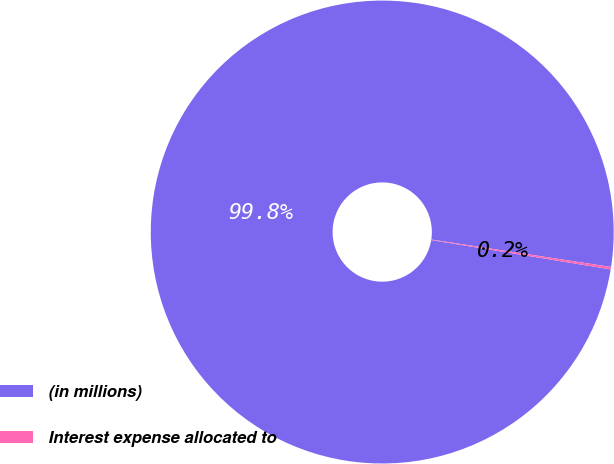Convert chart. <chart><loc_0><loc_0><loc_500><loc_500><pie_chart><fcel>(in millions)<fcel>Interest expense allocated to<nl><fcel>99.83%<fcel>0.17%<nl></chart> 